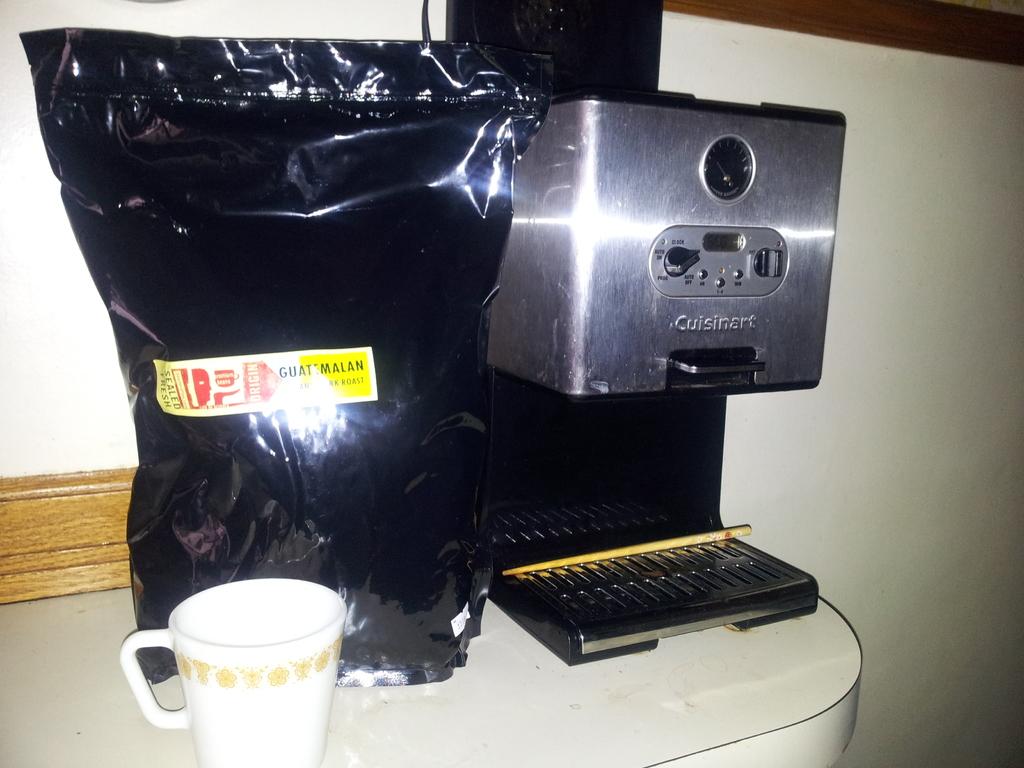What brand of coffee maker is that?
Give a very brief answer. Cuisinart. 